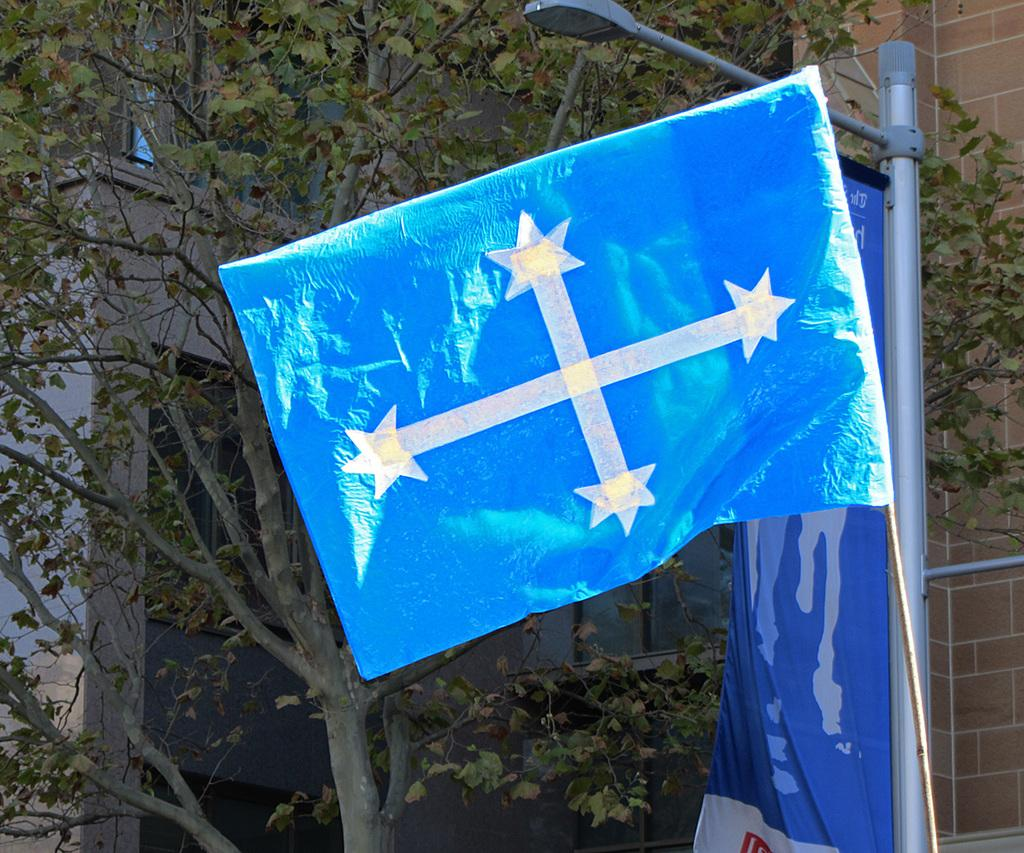What is located on the right side of the image? There is a flag on the right side of the image. What can be seen in the background of the image? There is a building and trees in the background of the image. How many pairs of shoes are hanging from the trees in the image? There are no shoes hanging from the trees in the image; only a flag, a building, and trees are present. What type of thread is used to create the flag in the image? The type of thread used to create the flag is not visible in the image, and therefore cannot be determined. 